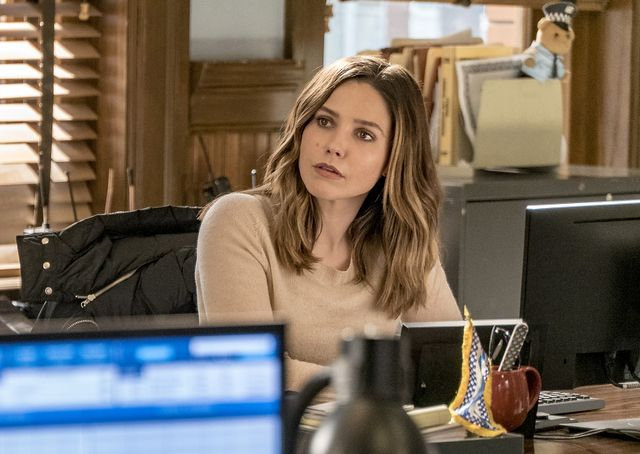What sort of work do you think the person in the image is engaged in? Considering the office context and the focused demeanor of the individual, she could likely be engaged in a profession that requires attention to detail, problem-solving, or critical thinking. Without more specific information, it's difficult to determine the exact nature of her work, but the environment suggests administrative, managerial, or creative fields could be possibilities. 